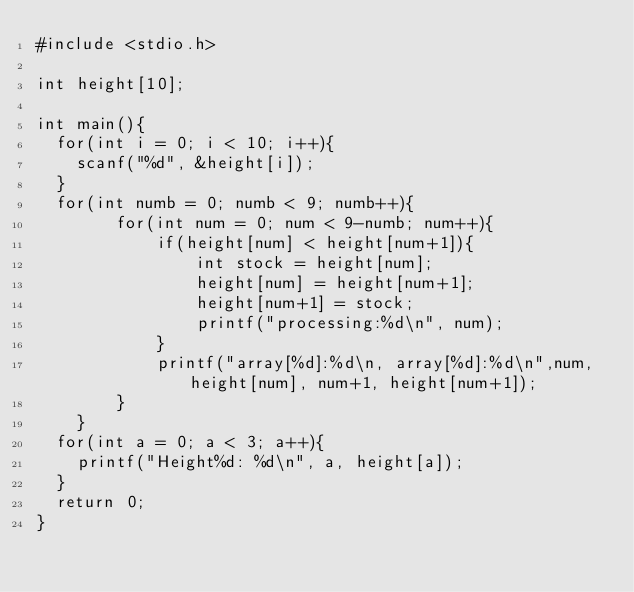Convert code to text. <code><loc_0><loc_0><loc_500><loc_500><_C_>#include <stdio.h>

int height[10];

int main(){
  for(int i = 0; i < 10; i++){
    scanf("%d", &height[i]);
  }
  for(int numb = 0; numb < 9; numb++){
        for(int num = 0; num < 9-numb; num++){
            if(height[num] < height[num+1]){
                int stock = height[num];
                height[num] = height[num+1];
                height[num+1] = stock;
                printf("processing:%d\n", num);
            }
            printf("array[%d]:%d\n, array[%d]:%d\n",num,height[num], num+1, height[num+1]);
        }
    }
  for(int a = 0; a < 3; a++){
    printf("Height%d: %d\n", a, height[a]); 
  }
  return 0;
}</code> 